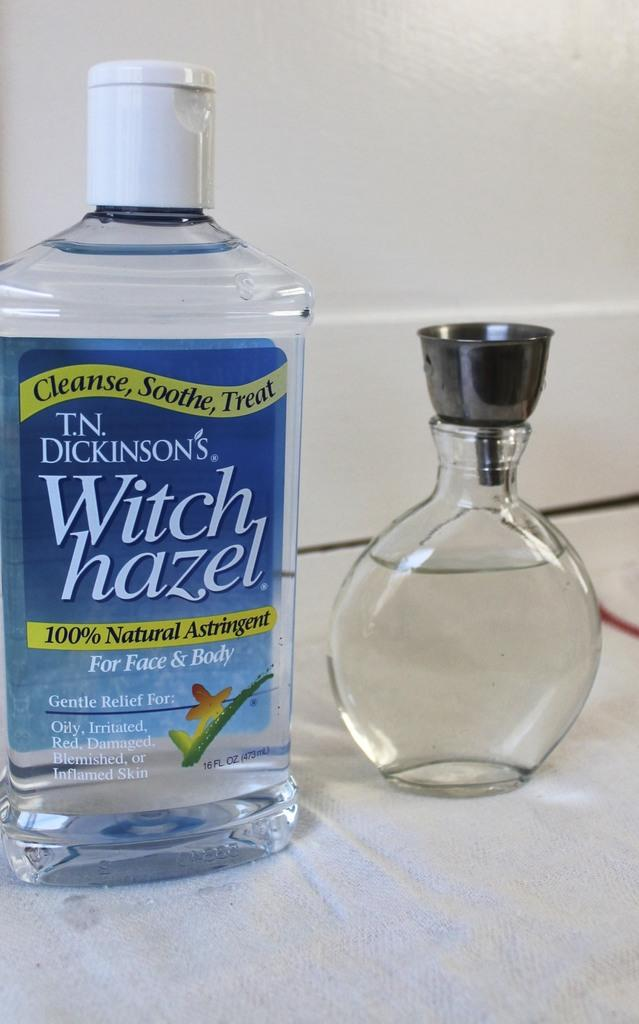<image>
Write a terse but informative summary of the picture. a bottle of t.n. dickinsons witch hazel that says 'cleanse, soothe, treat' on it 